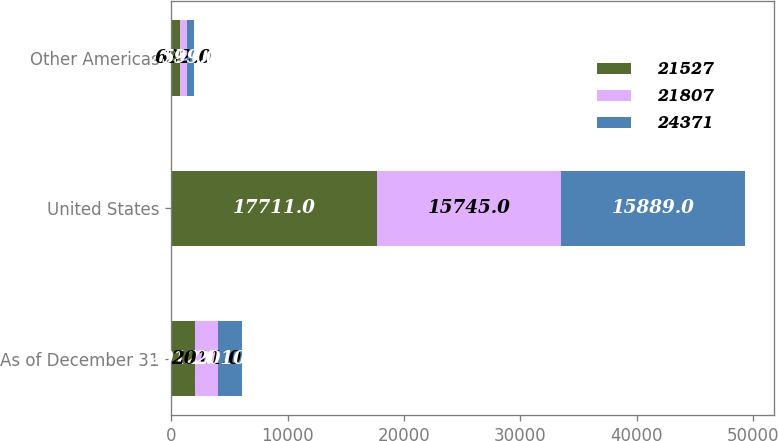Convert chart. <chart><loc_0><loc_0><loc_500><loc_500><stacked_bar_chart><ecel><fcel>As of December 31<fcel>United States<fcel>Other Americas<nl><fcel>21527<fcel>2012<fcel>17711<fcel>752<nl><fcel>21807<fcel>2011<fcel>15745<fcel>622<nl><fcel>24371<fcel>2010<fcel>15889<fcel>599<nl></chart> 